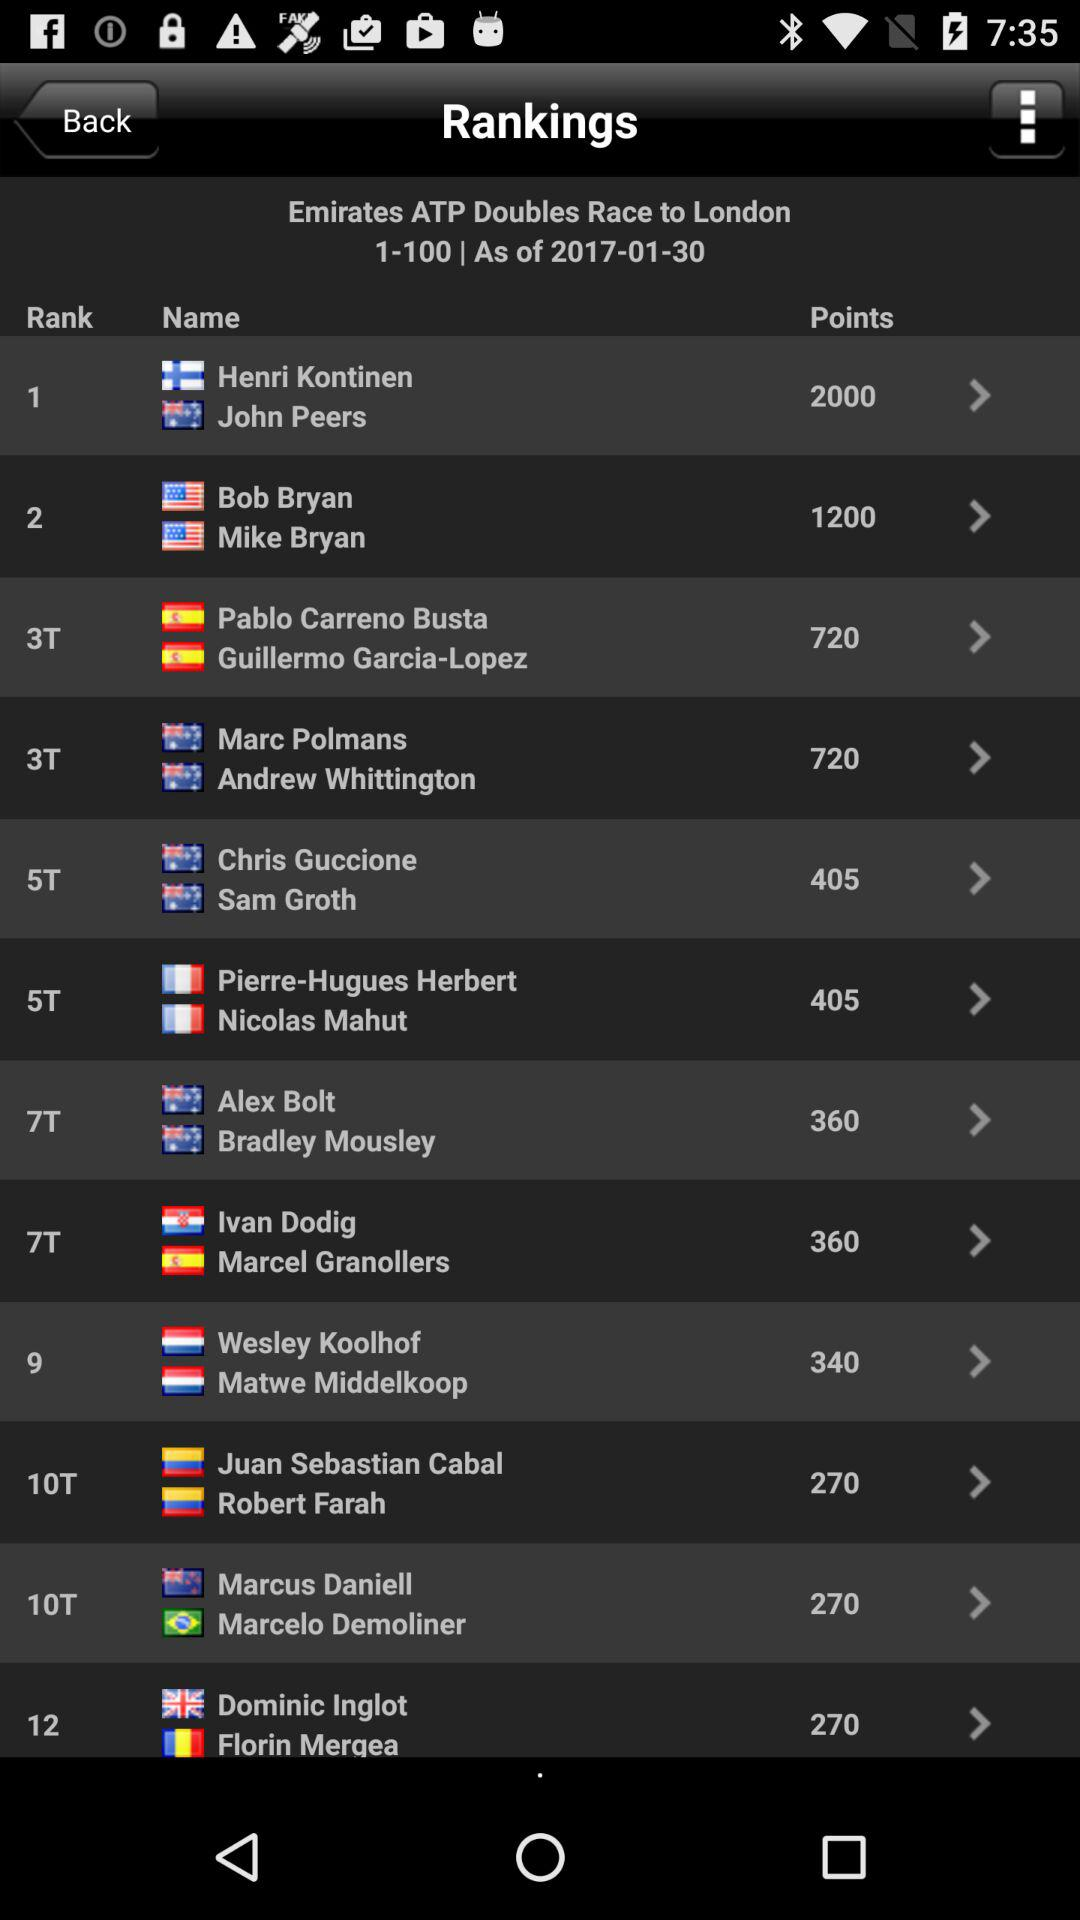Who has the rank of 10T? The rank of 10T has been earned by Juan Sebastian Cabal and Robert Farah. 